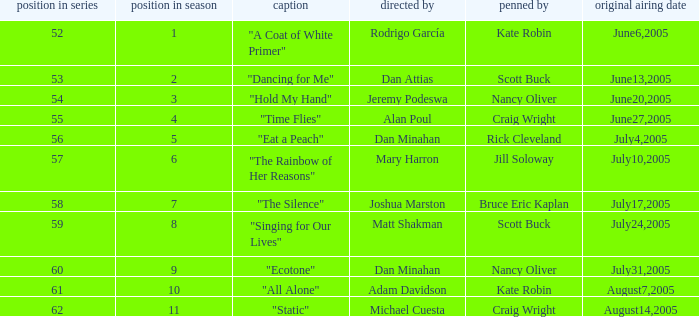What was the name of the episode that was directed by Mary Harron? "The Rainbow of Her Reasons". 